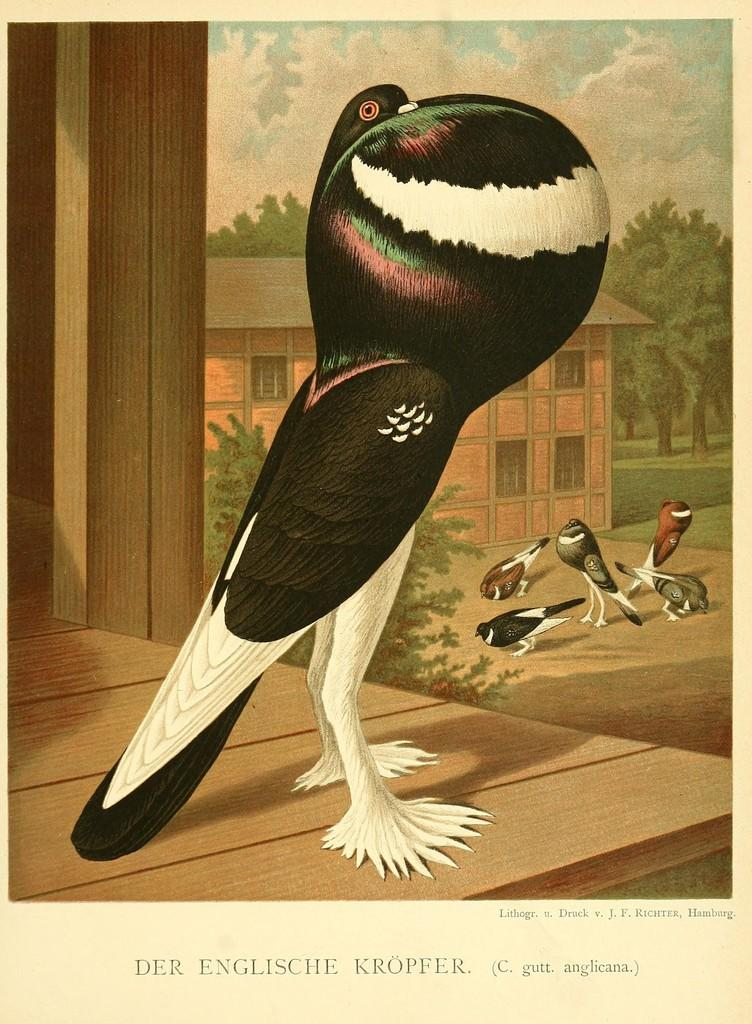What is featured on the poster in the picture? The poster contains images of birds, a house, and trees. What type of images are on the poster? The poster contains images of birds, a house, and trees. What can be seen in the sky in the picture? There are clouds visible in the sky. What type of hook is visible on the poster in the image? There is no hook present on the poster in the image. What type of store is depicted in the image? There is no store depicted in the image; it features a poster with images of birds, a house, and trees. 